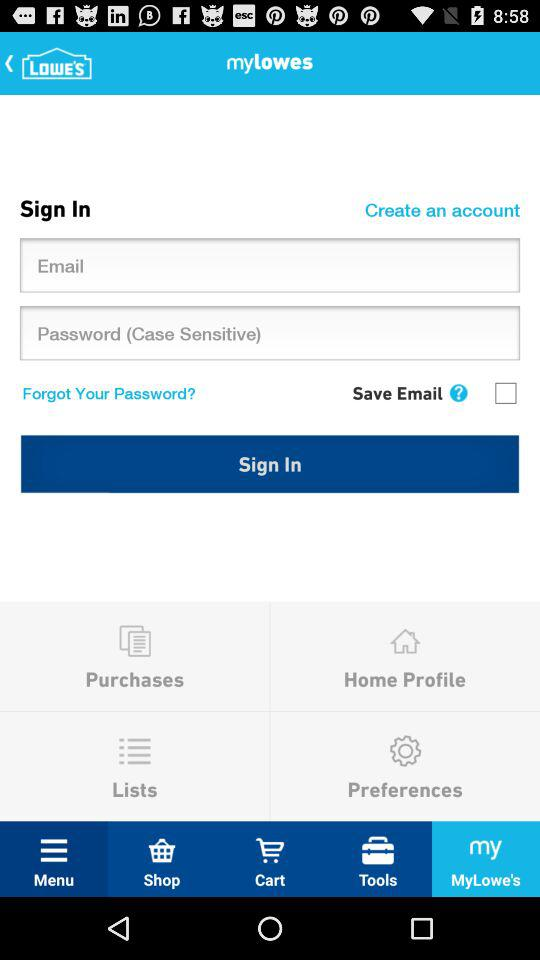What is the application name? The application name is "LOWE'S". 